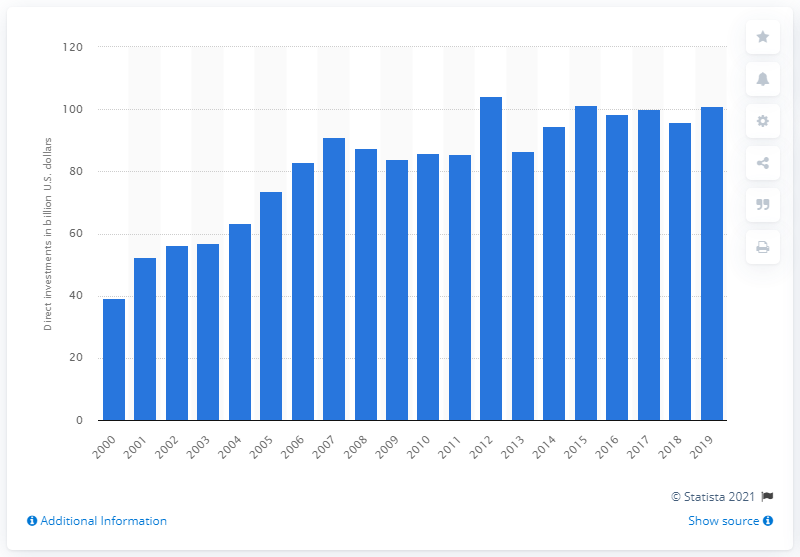Identify some key points in this picture. In 2019, a total of 100.89 dollars were invested in Europe. 